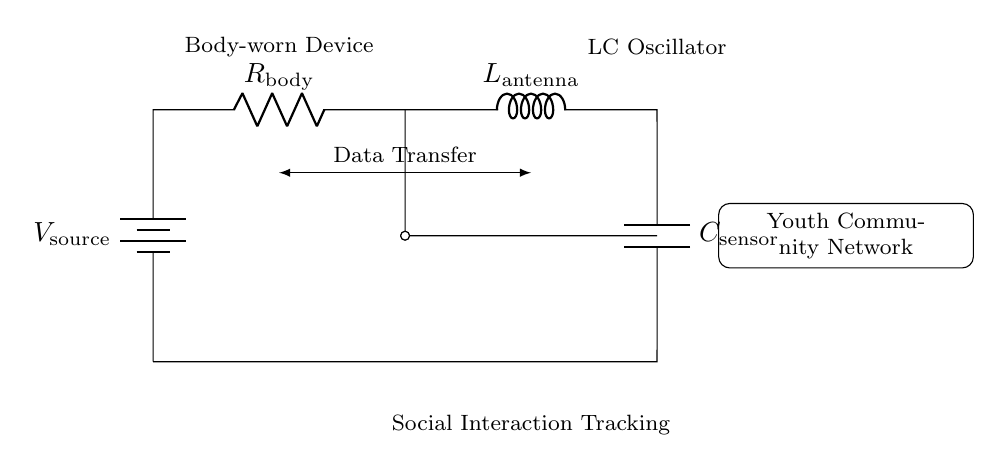What does the circuit primarily use for tracking? The circuit uses an LC oscillator, which consists of an inductor and a capacitor, specifically designed for oscillation in the context of monitoring social interactions.
Answer: LC oscillator What component represents resistance in this circuit? The resistance in this circuit is represented by the resistor labeled as R_body, which is essential for limiting current and stabilizing the oscillator's behavior.
Answer: R_body What is the role of the inductor in this circuit? The inductor labeled L_antenna plays a crucial role in the LC oscillator by storing energy in a magnetic field, which is essential for generating oscillations necessary for communication and data transfer.
Answer: L_antenna How do the capacitor and inductor work together in this circuit? The capacitor (C_sensor) and inductor (L_antenna) work together to create a resonant frequency in the LC circuit, allowing the device to oscillate at a specific frequency to track social interaction data effectively.
Answer: Resonant frequency What type of device is this circuit designed for? The circuit is designed for a body-worn device, which implies it is intended to be worn on a person to monitor and track their social interactions within youth communities.
Answer: Body-worn device What does the voltage source represent in this circuit? The voltage source represents the power supply for the circuit, providing the necessary electrical energy to drive the LC oscillator and enable operation.
Answer: Voltage source 